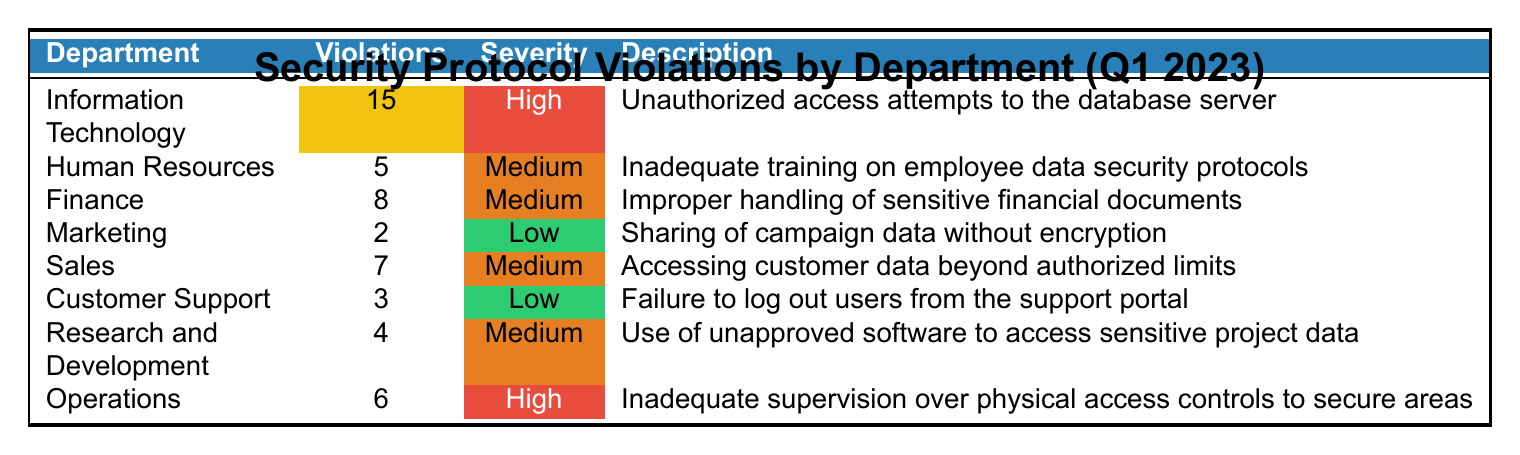What is the total number of security protocol violations across all departments? To find the total number of violations, we sum the "ViolationCount" for each department: 15 + 5 + 8 + 2 + 7 + 3 + 4 + 6 = 50.
Answer: 50 Which department had the highest number of violations? Looking at the "ViolationCount," Information Technology has the highest count at 15.
Answer: Information Technology How many departments experienced high severity violations? There are two departments marked as high severity: Information Technology and Operations.
Answer: 2 What is the average number of violations for the departments with medium severity? The departments with medium severity have counts of 5 (HR), 8 (Finance), 7 (Sales), and 4 (R&D), totaling 24 violations. There are 4 such departments, so the average is 24/4 = 6.
Answer: 6 Is it true that the Marketing department had more violations than the Customer Support department? Marketing had 2 violations while Customer Support had 3, so it's false that Marketing had more.
Answer: No Which department had violations related to inadequate training? The Human Resources department had violations described as inadequate training on employee data security protocols.
Answer: Human Resources What is the total count of low severity violations? Only Marketing (2) and Customer Support (3) had low severity violations, summing to 2 + 3 = 5.
Answer: 5 How many departments had at least as many violations as Operations? Operations had 6 violations; Information Technology (15), Finance (8), and Sales (7) had more, while Human Resources (5) and others had fewer. That's a total of 4 departments.
Answer: 4 What percentage of total violations were high severity violations? There are 2 high severity violations (IT and Operations), which makes up (2/50) * 100% = 4%.
Answer: 4% 